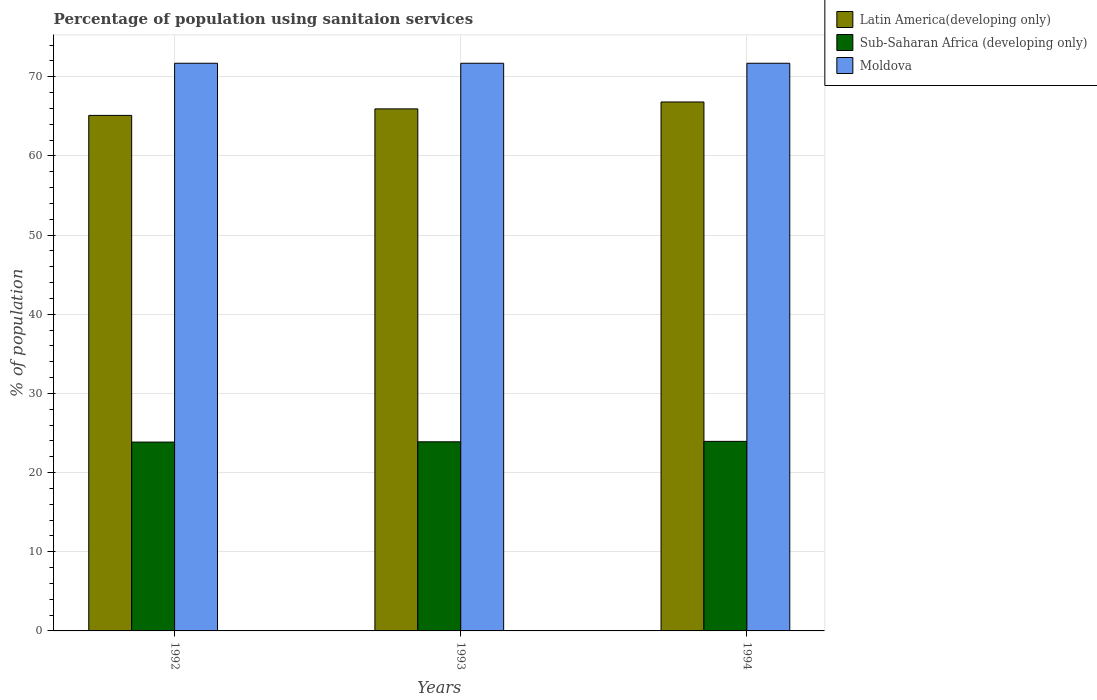How many different coloured bars are there?
Give a very brief answer. 3. How many groups of bars are there?
Keep it short and to the point. 3. Are the number of bars per tick equal to the number of legend labels?
Provide a succinct answer. Yes. How many bars are there on the 2nd tick from the left?
Offer a very short reply. 3. How many bars are there on the 2nd tick from the right?
Make the answer very short. 3. What is the percentage of population using sanitaion services in Sub-Saharan Africa (developing only) in 1992?
Provide a short and direct response. 23.85. Across all years, what is the maximum percentage of population using sanitaion services in Sub-Saharan Africa (developing only)?
Ensure brevity in your answer.  23.94. Across all years, what is the minimum percentage of population using sanitaion services in Latin America(developing only)?
Provide a short and direct response. 65.11. What is the total percentage of population using sanitaion services in Moldova in the graph?
Offer a very short reply. 215.1. What is the difference between the percentage of population using sanitaion services in Latin America(developing only) in 1992 and that in 1993?
Your response must be concise. -0.82. What is the difference between the percentage of population using sanitaion services in Sub-Saharan Africa (developing only) in 1993 and the percentage of population using sanitaion services in Moldova in 1994?
Ensure brevity in your answer.  -47.81. What is the average percentage of population using sanitaion services in Latin America(developing only) per year?
Your answer should be compact. 65.95. In the year 1993, what is the difference between the percentage of population using sanitaion services in Moldova and percentage of population using sanitaion services in Latin America(developing only)?
Offer a very short reply. 5.76. In how many years, is the percentage of population using sanitaion services in Sub-Saharan Africa (developing only) greater than 48 %?
Provide a succinct answer. 0. What is the ratio of the percentage of population using sanitaion services in Sub-Saharan Africa (developing only) in 1993 to that in 1994?
Offer a very short reply. 1. Is the percentage of population using sanitaion services in Sub-Saharan Africa (developing only) in 1992 less than that in 1993?
Provide a succinct answer. Yes. What is the difference between the highest and the lowest percentage of population using sanitaion services in Moldova?
Offer a very short reply. 0. In how many years, is the percentage of population using sanitaion services in Latin America(developing only) greater than the average percentage of population using sanitaion services in Latin America(developing only) taken over all years?
Your answer should be very brief. 1. Is the sum of the percentage of population using sanitaion services in Latin America(developing only) in 1992 and 1994 greater than the maximum percentage of population using sanitaion services in Moldova across all years?
Make the answer very short. Yes. What does the 2nd bar from the left in 1994 represents?
Make the answer very short. Sub-Saharan Africa (developing only). What does the 2nd bar from the right in 1994 represents?
Ensure brevity in your answer.  Sub-Saharan Africa (developing only). Is it the case that in every year, the sum of the percentage of population using sanitaion services in Moldova and percentage of population using sanitaion services in Latin America(developing only) is greater than the percentage of population using sanitaion services in Sub-Saharan Africa (developing only)?
Make the answer very short. Yes. Are all the bars in the graph horizontal?
Ensure brevity in your answer.  No. Does the graph contain any zero values?
Provide a succinct answer. No. Does the graph contain grids?
Your answer should be compact. Yes. How many legend labels are there?
Provide a short and direct response. 3. What is the title of the graph?
Provide a succinct answer. Percentage of population using sanitaion services. Does "Zambia" appear as one of the legend labels in the graph?
Give a very brief answer. No. What is the label or title of the X-axis?
Provide a succinct answer. Years. What is the label or title of the Y-axis?
Provide a short and direct response. % of population. What is the % of population in Latin America(developing only) in 1992?
Offer a terse response. 65.11. What is the % of population of Sub-Saharan Africa (developing only) in 1992?
Keep it short and to the point. 23.85. What is the % of population in Moldova in 1992?
Offer a terse response. 71.7. What is the % of population in Latin America(developing only) in 1993?
Make the answer very short. 65.94. What is the % of population of Sub-Saharan Africa (developing only) in 1993?
Give a very brief answer. 23.89. What is the % of population of Moldova in 1993?
Give a very brief answer. 71.7. What is the % of population of Latin America(developing only) in 1994?
Provide a short and direct response. 66.81. What is the % of population in Sub-Saharan Africa (developing only) in 1994?
Make the answer very short. 23.94. What is the % of population of Moldova in 1994?
Your response must be concise. 71.7. Across all years, what is the maximum % of population of Latin America(developing only)?
Give a very brief answer. 66.81. Across all years, what is the maximum % of population of Sub-Saharan Africa (developing only)?
Make the answer very short. 23.94. Across all years, what is the maximum % of population in Moldova?
Your response must be concise. 71.7. Across all years, what is the minimum % of population of Latin America(developing only)?
Offer a terse response. 65.11. Across all years, what is the minimum % of population in Sub-Saharan Africa (developing only)?
Your answer should be very brief. 23.85. Across all years, what is the minimum % of population of Moldova?
Ensure brevity in your answer.  71.7. What is the total % of population of Latin America(developing only) in the graph?
Give a very brief answer. 197.86. What is the total % of population of Sub-Saharan Africa (developing only) in the graph?
Your answer should be very brief. 71.68. What is the total % of population of Moldova in the graph?
Ensure brevity in your answer.  215.1. What is the difference between the % of population of Latin America(developing only) in 1992 and that in 1993?
Provide a succinct answer. -0.82. What is the difference between the % of population in Sub-Saharan Africa (developing only) in 1992 and that in 1993?
Ensure brevity in your answer.  -0.04. What is the difference between the % of population in Latin America(developing only) in 1992 and that in 1994?
Make the answer very short. -1.7. What is the difference between the % of population of Sub-Saharan Africa (developing only) in 1992 and that in 1994?
Your answer should be very brief. -0.09. What is the difference between the % of population of Moldova in 1992 and that in 1994?
Provide a short and direct response. 0. What is the difference between the % of population in Latin America(developing only) in 1993 and that in 1994?
Offer a very short reply. -0.87. What is the difference between the % of population of Sub-Saharan Africa (developing only) in 1993 and that in 1994?
Your answer should be compact. -0.05. What is the difference between the % of population of Latin America(developing only) in 1992 and the % of population of Sub-Saharan Africa (developing only) in 1993?
Your response must be concise. 41.23. What is the difference between the % of population in Latin America(developing only) in 1992 and the % of population in Moldova in 1993?
Ensure brevity in your answer.  -6.59. What is the difference between the % of population in Sub-Saharan Africa (developing only) in 1992 and the % of population in Moldova in 1993?
Your answer should be very brief. -47.85. What is the difference between the % of population of Latin America(developing only) in 1992 and the % of population of Sub-Saharan Africa (developing only) in 1994?
Your answer should be compact. 41.17. What is the difference between the % of population of Latin America(developing only) in 1992 and the % of population of Moldova in 1994?
Keep it short and to the point. -6.59. What is the difference between the % of population in Sub-Saharan Africa (developing only) in 1992 and the % of population in Moldova in 1994?
Your answer should be very brief. -47.85. What is the difference between the % of population in Latin America(developing only) in 1993 and the % of population in Sub-Saharan Africa (developing only) in 1994?
Your answer should be compact. 41.99. What is the difference between the % of population in Latin America(developing only) in 1993 and the % of population in Moldova in 1994?
Your answer should be very brief. -5.76. What is the difference between the % of population of Sub-Saharan Africa (developing only) in 1993 and the % of population of Moldova in 1994?
Ensure brevity in your answer.  -47.81. What is the average % of population of Latin America(developing only) per year?
Your answer should be very brief. 65.95. What is the average % of population in Sub-Saharan Africa (developing only) per year?
Your answer should be compact. 23.89. What is the average % of population in Moldova per year?
Keep it short and to the point. 71.7. In the year 1992, what is the difference between the % of population of Latin America(developing only) and % of population of Sub-Saharan Africa (developing only)?
Offer a very short reply. 41.26. In the year 1992, what is the difference between the % of population in Latin America(developing only) and % of population in Moldova?
Your response must be concise. -6.59. In the year 1992, what is the difference between the % of population of Sub-Saharan Africa (developing only) and % of population of Moldova?
Your answer should be compact. -47.85. In the year 1993, what is the difference between the % of population in Latin America(developing only) and % of population in Sub-Saharan Africa (developing only)?
Ensure brevity in your answer.  42.05. In the year 1993, what is the difference between the % of population of Latin America(developing only) and % of population of Moldova?
Ensure brevity in your answer.  -5.76. In the year 1993, what is the difference between the % of population of Sub-Saharan Africa (developing only) and % of population of Moldova?
Give a very brief answer. -47.81. In the year 1994, what is the difference between the % of population in Latin America(developing only) and % of population in Sub-Saharan Africa (developing only)?
Your answer should be very brief. 42.87. In the year 1994, what is the difference between the % of population in Latin America(developing only) and % of population in Moldova?
Provide a succinct answer. -4.89. In the year 1994, what is the difference between the % of population of Sub-Saharan Africa (developing only) and % of population of Moldova?
Ensure brevity in your answer.  -47.76. What is the ratio of the % of population of Latin America(developing only) in 1992 to that in 1993?
Make the answer very short. 0.99. What is the ratio of the % of population in Sub-Saharan Africa (developing only) in 1992 to that in 1993?
Make the answer very short. 1. What is the ratio of the % of population in Latin America(developing only) in 1992 to that in 1994?
Ensure brevity in your answer.  0.97. What is the ratio of the % of population in Moldova in 1992 to that in 1994?
Keep it short and to the point. 1. What is the ratio of the % of population of Latin America(developing only) in 1993 to that in 1994?
Offer a terse response. 0.99. What is the ratio of the % of population of Sub-Saharan Africa (developing only) in 1993 to that in 1994?
Ensure brevity in your answer.  1. What is the difference between the highest and the second highest % of population of Latin America(developing only)?
Your answer should be very brief. 0.87. What is the difference between the highest and the second highest % of population in Sub-Saharan Africa (developing only)?
Keep it short and to the point. 0.05. What is the difference between the highest and the second highest % of population in Moldova?
Offer a very short reply. 0. What is the difference between the highest and the lowest % of population of Latin America(developing only)?
Offer a very short reply. 1.7. What is the difference between the highest and the lowest % of population in Sub-Saharan Africa (developing only)?
Your answer should be compact. 0.09. 